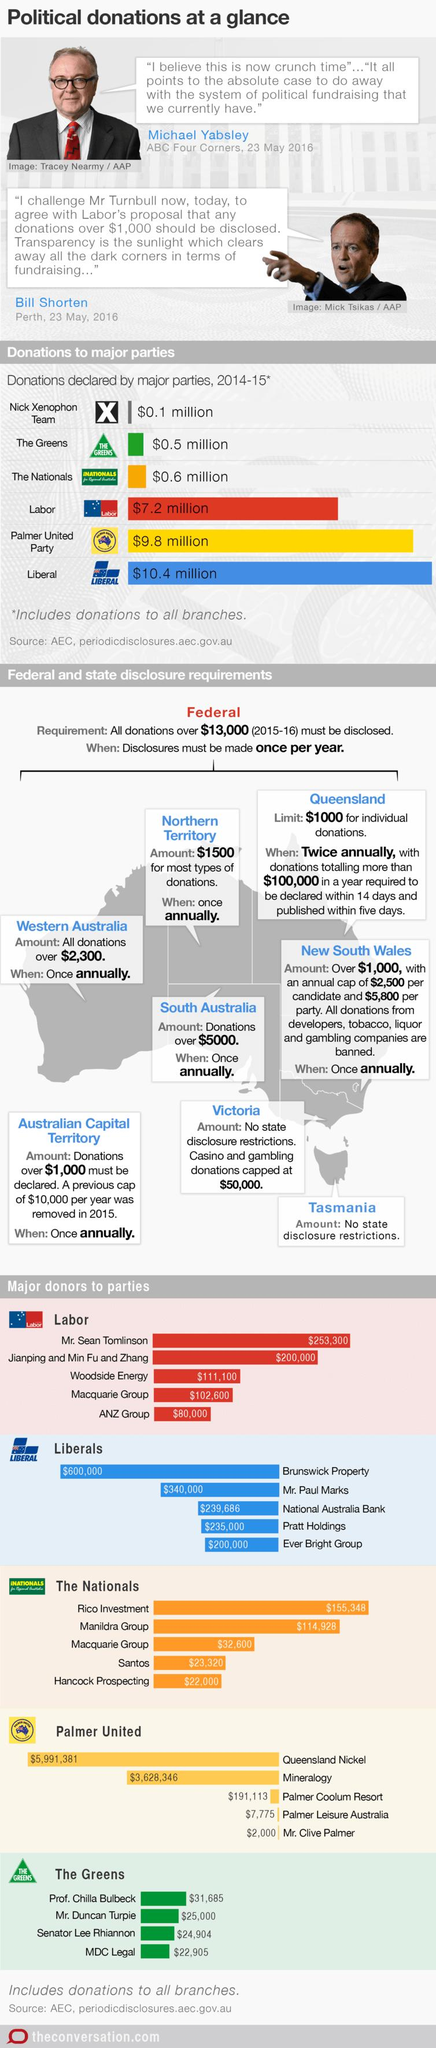Draw attention to some important aspects in this diagram. The Palmer United Party and Liberal donated a total of 11.2 million dollars. The Nick Xenophon Team logo contains a distinct alphabet that is written inside and the letter X is represented by a symbol. The second highest donor to the Labor party was Jianping, Min Fu, and Zhang. MDC Legal and Mr. Duncan Turpie donated $47,905 to the Greens. The Nick Xenophon Team and The Greens have donated a total of 0.6 million dollars. 